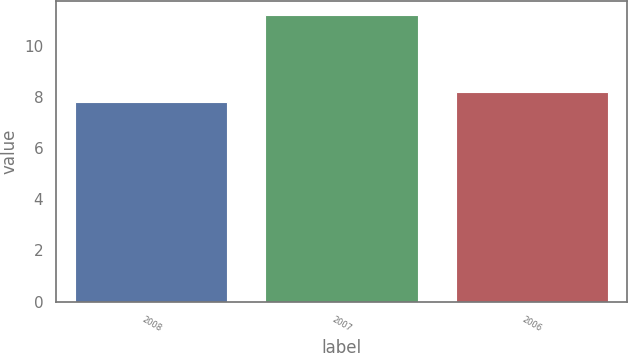<chart> <loc_0><loc_0><loc_500><loc_500><bar_chart><fcel>2008<fcel>2007<fcel>2006<nl><fcel>7.8<fcel>11.2<fcel>8.2<nl></chart> 